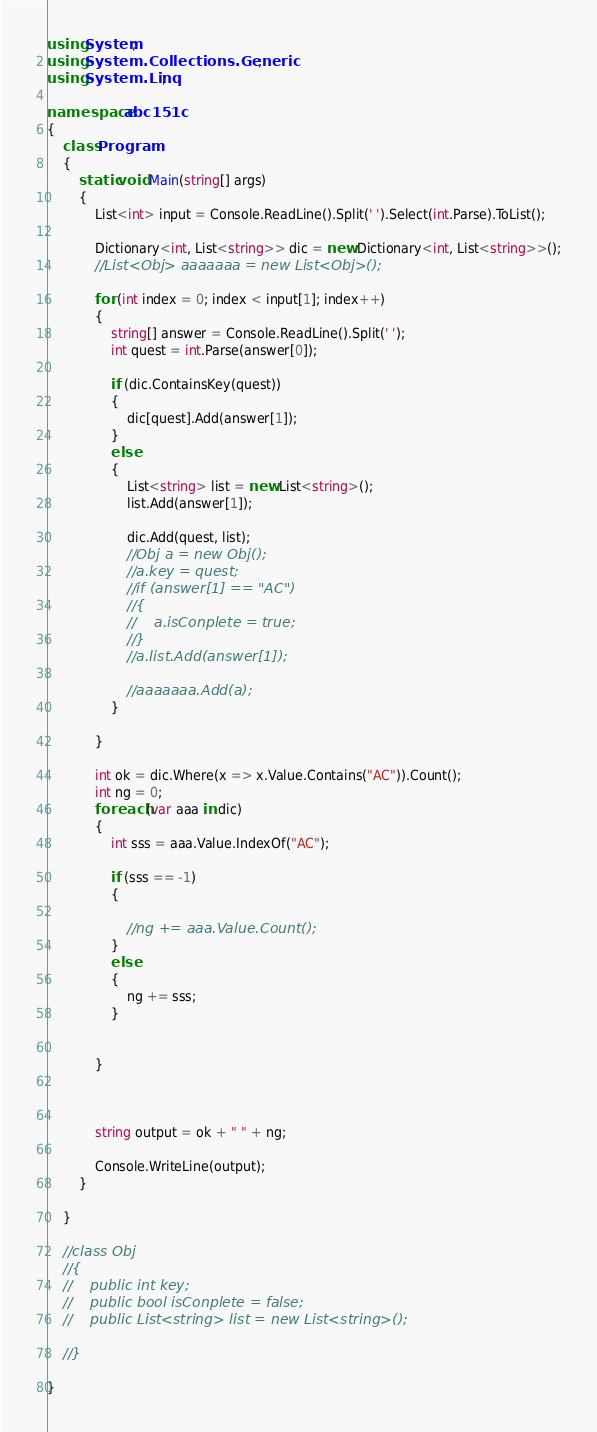Convert code to text. <code><loc_0><loc_0><loc_500><loc_500><_C#_>using System;
using System.Collections.Generic;
using System.Linq;

namespace abc151c
{
    class Program
    {
        static void Main(string[] args)
        {
            List<int> input = Console.ReadLine().Split(' ').Select(int.Parse).ToList();

            Dictionary<int, List<string>> dic = new Dictionary<int, List<string>>();
            //List<Obj> aaaaaaa = new List<Obj>();

            for (int index = 0; index < input[1]; index++)
            {
                string[] answer = Console.ReadLine().Split(' ');
                int quest = int.Parse(answer[0]);

                if (dic.ContainsKey(quest))
                {
                    dic[quest].Add(answer[1]);
                }
                else
                {
                    List<string> list = new List<string>();
                    list.Add(answer[1]);

                    dic.Add(quest, list);
                    //Obj a = new Obj();
                    //a.key = quest;
                    //if (answer[1] == "AC")
                    //{
                    //    a.isConplete = true;
                    //}
                    //a.list.Add(answer[1]);

                    //aaaaaaa.Add(a);
                }

            }

            int ok = dic.Where(x => x.Value.Contains("AC")).Count();
            int ng = 0;
            foreach (var aaa in dic)
            {
                int sss = aaa.Value.IndexOf("AC");

                if (sss == -1)
                {

                    //ng += aaa.Value.Count();
                }
                else
                {
                    ng += sss;
                }


            }



            string output = ok + " " + ng;

            Console.WriteLine(output);
        }

    }

    //class Obj
    //{
    //    public int key;
    //    public bool isConplete = false;
    //    public List<string> list = new List<string>();

    //}

}
</code> 